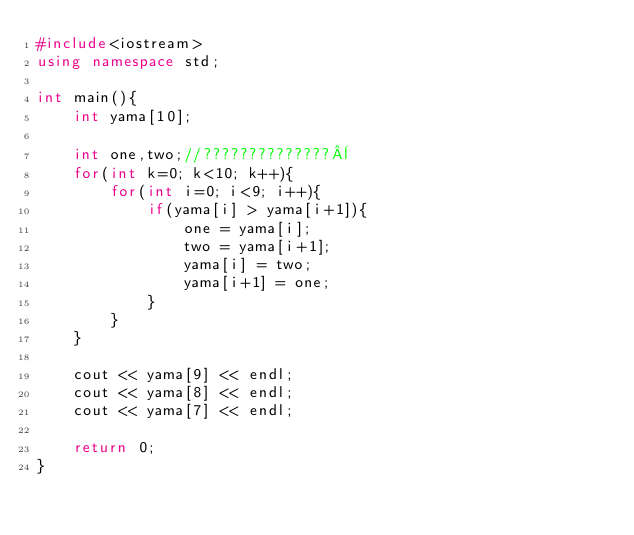Convert code to text. <code><loc_0><loc_0><loc_500><loc_500><_C++_>#include<iostream>
using namespace std;

int main(){
	int yama[10];
	
	int one,two;//??????????????¨
	for(int k=0; k<10; k++){
		for(int i=0; i<9; i++){
			if(yama[i] > yama[i+1]){
				one = yama[i];
				two = yama[i+1];
				yama[i] = two;
				yama[i+1] = one;
			}
		}
	}

	cout << yama[9] << endl;
	cout << yama[8] << endl;
	cout << yama[7] << endl;

	return 0;
}</code> 